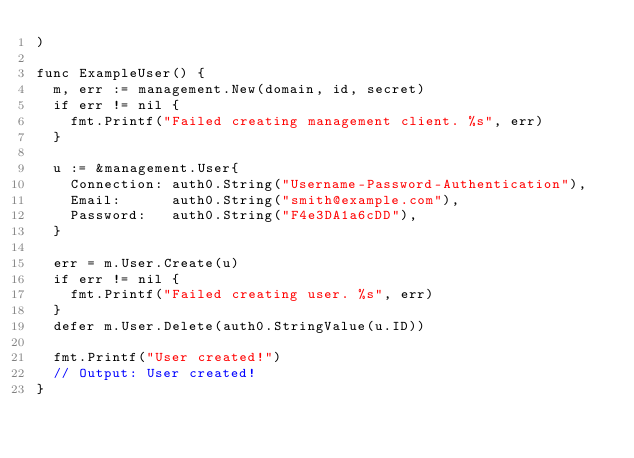<code> <loc_0><loc_0><loc_500><loc_500><_Go_>)

func ExampleUser() {
	m, err := management.New(domain, id, secret)
	if err != nil {
		fmt.Printf("Failed creating management client. %s", err)
	}

	u := &management.User{
		Connection: auth0.String("Username-Password-Authentication"),
		Email:      auth0.String("smith@example.com"),
		Password:   auth0.String("F4e3DA1a6cDD"),
	}

	err = m.User.Create(u)
	if err != nil {
		fmt.Printf("Failed creating user. %s", err)
	}
	defer m.User.Delete(auth0.StringValue(u.ID))

	fmt.Printf("User created!")
	// Output: User created!
}
</code> 